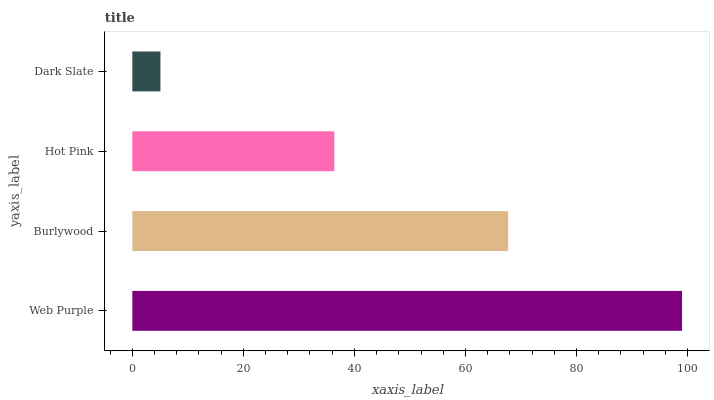Is Dark Slate the minimum?
Answer yes or no. Yes. Is Web Purple the maximum?
Answer yes or no. Yes. Is Burlywood the minimum?
Answer yes or no. No. Is Burlywood the maximum?
Answer yes or no. No. Is Web Purple greater than Burlywood?
Answer yes or no. Yes. Is Burlywood less than Web Purple?
Answer yes or no. Yes. Is Burlywood greater than Web Purple?
Answer yes or no. No. Is Web Purple less than Burlywood?
Answer yes or no. No. Is Burlywood the high median?
Answer yes or no. Yes. Is Hot Pink the low median?
Answer yes or no. Yes. Is Web Purple the high median?
Answer yes or no. No. Is Dark Slate the low median?
Answer yes or no. No. 